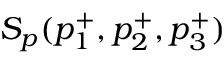Convert formula to latex. <formula><loc_0><loc_0><loc_500><loc_500>S _ { p } ( p _ { 1 } ^ { + } , p _ { 2 } ^ { + } , p _ { 3 } ^ { + } )</formula> 